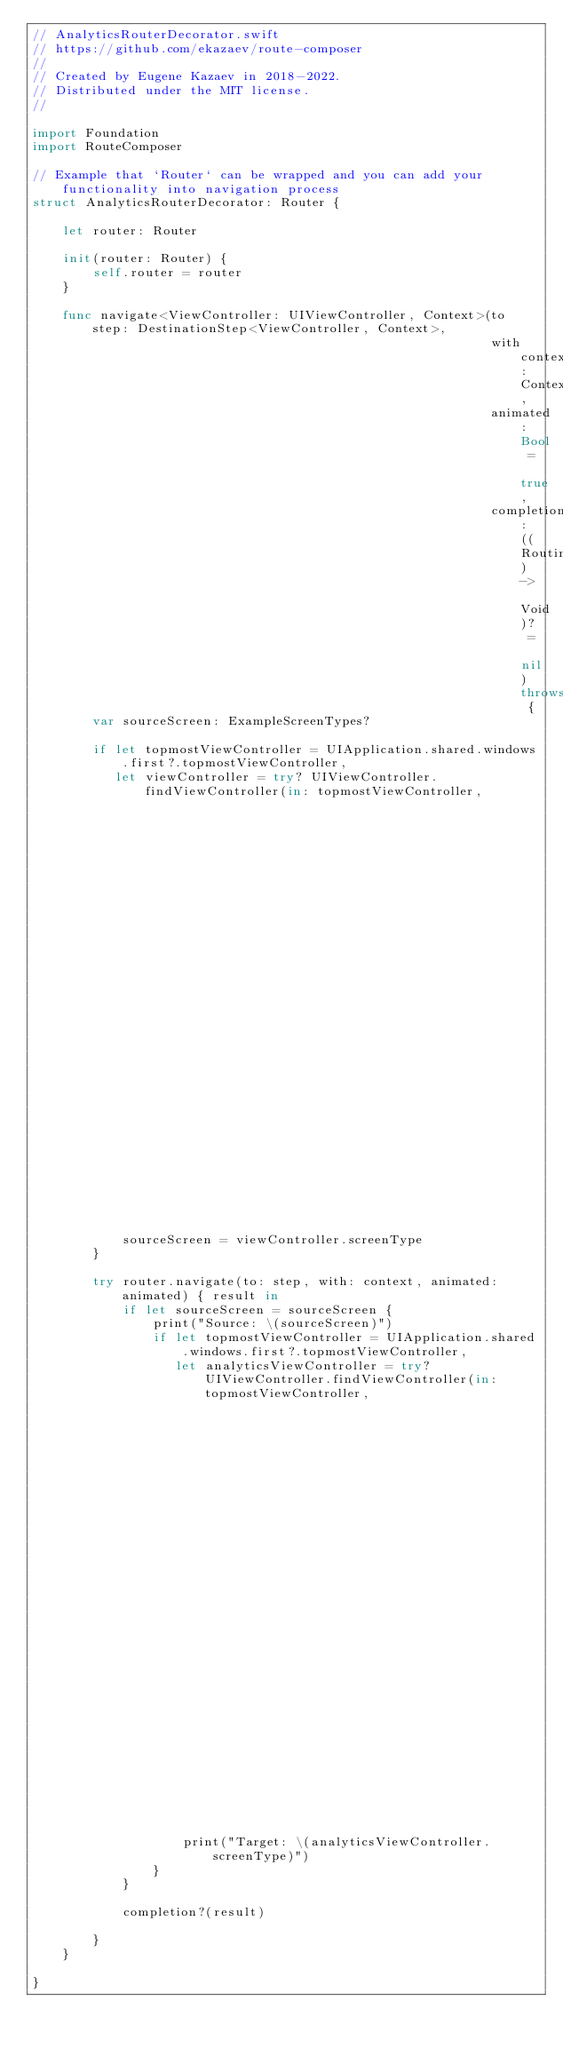Convert code to text. <code><loc_0><loc_0><loc_500><loc_500><_Swift_>// AnalyticsRouterDecorator.swift
// https://github.com/ekazaev/route-composer
//
// Created by Eugene Kazaev in 2018-2022.
// Distributed under the MIT license.
//

import Foundation
import RouteComposer

// Example that `Router` can be wrapped and you can add your functionality into navigation process
struct AnalyticsRouterDecorator: Router {

    let router: Router

    init(router: Router) {
        self.router = router
    }

    func navigate<ViewController: UIViewController, Context>(to step: DestinationStep<ViewController, Context>,
                                                             with context: Context,
                                                             animated: Bool = true,
                                                             completion: ((RoutingResult) -> Void)? = nil) throws {
        var sourceScreen: ExampleScreenTypes?

        if let topmostViewController = UIApplication.shared.windows.first?.topmostViewController,
           let viewController = try? UIViewController.findViewController(in: topmostViewController,
                                                                         options: [.current, .visible],
                                                                         using: { $0 is ExampleAnalyticsSupport }) as? ExampleAnalyticsSupport {
            sourceScreen = viewController.screenType
        }

        try router.navigate(to: step, with: context, animated: animated) { result in
            if let sourceScreen = sourceScreen {
                print("Source: \(sourceScreen)")
                if let topmostViewController = UIApplication.shared.windows.first?.topmostViewController,
                   let analyticsViewController = try? UIViewController.findViewController(in: topmostViewController,
                                                                                          options: [.current, .visible],
                                                                                          using: { $0 is ExampleAnalyticsSupport }) as? ExampleAnalyticsSupport {
                    print("Target: \(analyticsViewController.screenType)")
                }
            }

            completion?(result)

        }
    }

}
</code> 